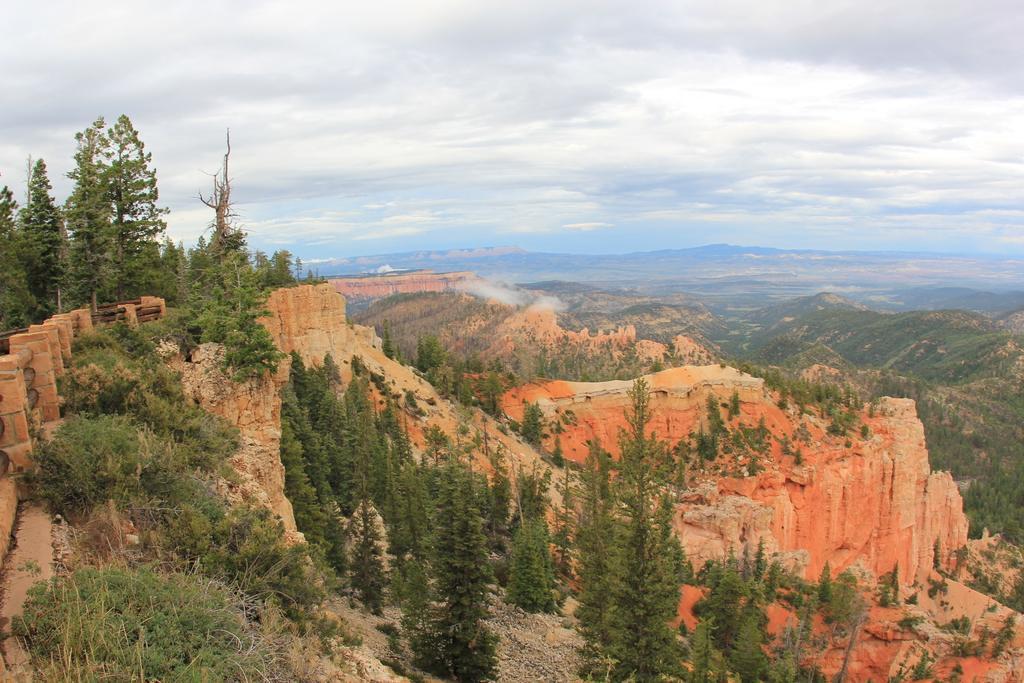How would you summarize this image in a sentence or two? In this image we can see, the mountains, rocks, there are plants, trees, also we can see the cloudy sky. 